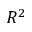Convert formula to latex. <formula><loc_0><loc_0><loc_500><loc_500>R ^ { 2 }</formula> 